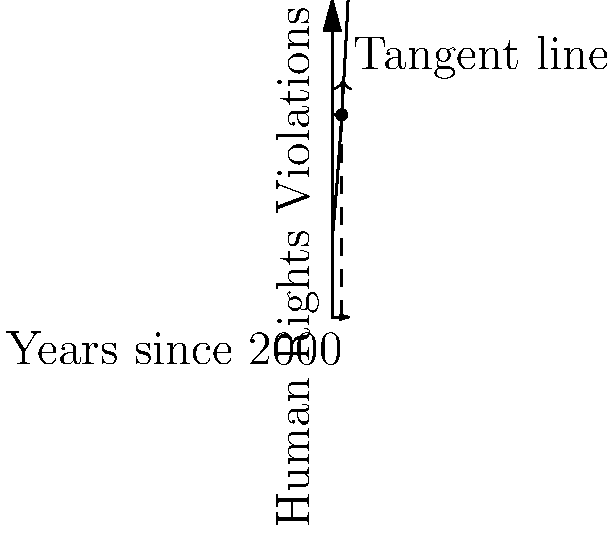The graph shows the trend of human rights violations in Afghanistan over time since the year 2000. The function modeling this trend is given by $f(x) = 50 + 10x + 0.5x^2$, where $x$ represents years since 2000 and $f(x)$ represents the number of reported violations. What does the slope of the tangent line at $x=6$ (i.e., the year 2006) indicate about the rate of change in human rights violations at that time? To interpret the slope of the tangent line at $x=6$, we need to follow these steps:

1) The slope of the tangent line is equal to the derivative of the function at that point.

2) To find the derivative, we differentiate $f(x) = 50 + 10x + 0.5x^2$:
   $f'(x) = 10 + x$

3) At $x=6$, the slope is:
   $f'(6) = 10 + 6 = 16$

4) Interpretation:
   - The slope is positive, indicating an increasing trend in violations.
   - The value 16 means that in 2006, the rate of change was 16 additional violations per year.
   - This suggests a rapid deterioration of human rights conditions at that time.

5) In the context of Afghan affairs:
   - This could correspond to increased conflict or political instability.
   - It might indicate a need for stronger international intervention or policy changes.
   - As a human rights expert, this trend would be a significant concern, potentially calling for immediate action or policy recommendations.
Answer: 16 additional violations per year in 2006, indicating rapidly worsening human rights conditions. 